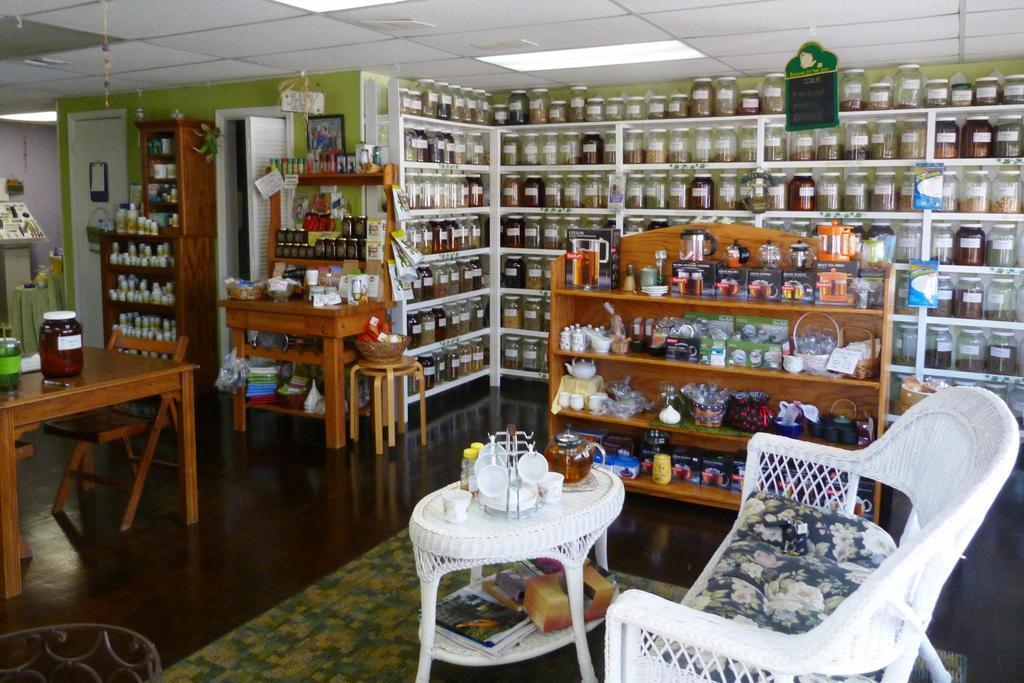How would you summarize this image in a sentence or two? In this image we can see some tables and a sofa, on the tables, we can see jars, bottles, cups and some other objects, there are some racks with jars, bottles and some other objects, also we can see a stool and a chair, on the tools, we can see a bowl with some things, at the top we can see the lights. 